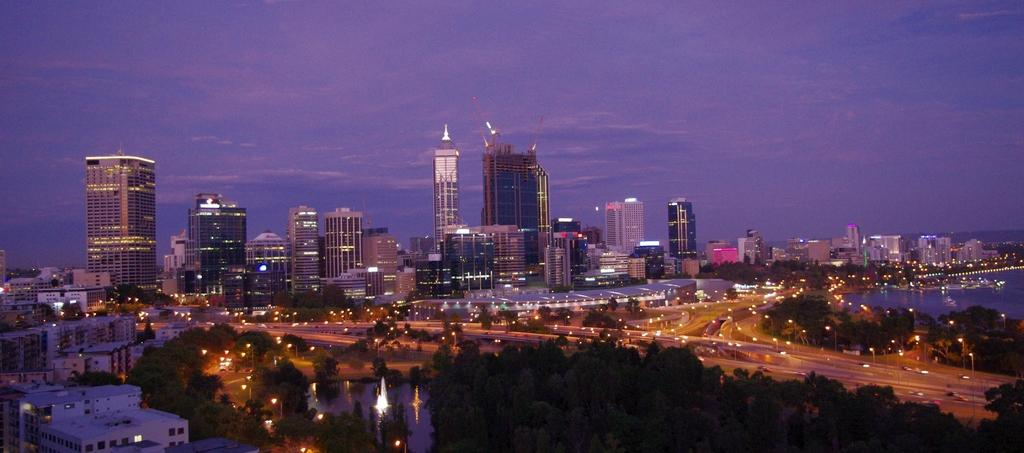What type of structures can be seen in the image? There are buildings in the image. What other natural elements are present in the image? There are trees in the image. What type of pathway is visible in the image? There is a road in the image. What body of water can be seen in the image? There is water visible in the image. What type of illumination is present in the image? There are lights in the image. What can be seen in the background of the image? The sky is visible in the background of the image. Where is the box located in the image? There is no box present in the image. What type of cracker is being held by the arm in the image? There is no arm or cracker present in the image. 